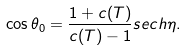<formula> <loc_0><loc_0><loc_500><loc_500>\cos \theta _ { 0 } = \frac { 1 + c ( T ) } { c ( T ) - 1 } s e c h \eta .</formula> 